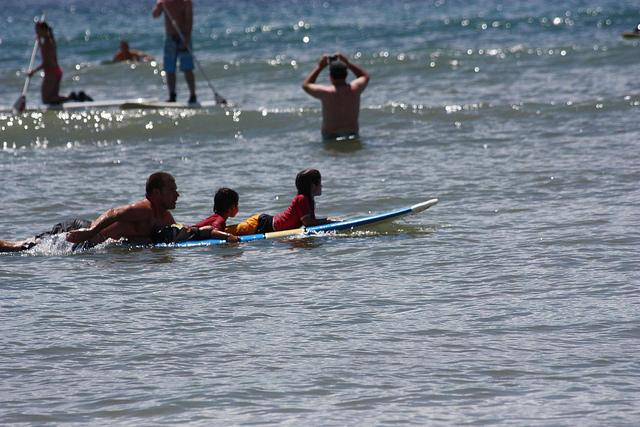What do the persons on boards here wish for?

Choices:
A) chocolate sundaes
B) calm water
C) big waves
D) doldrums big waves 